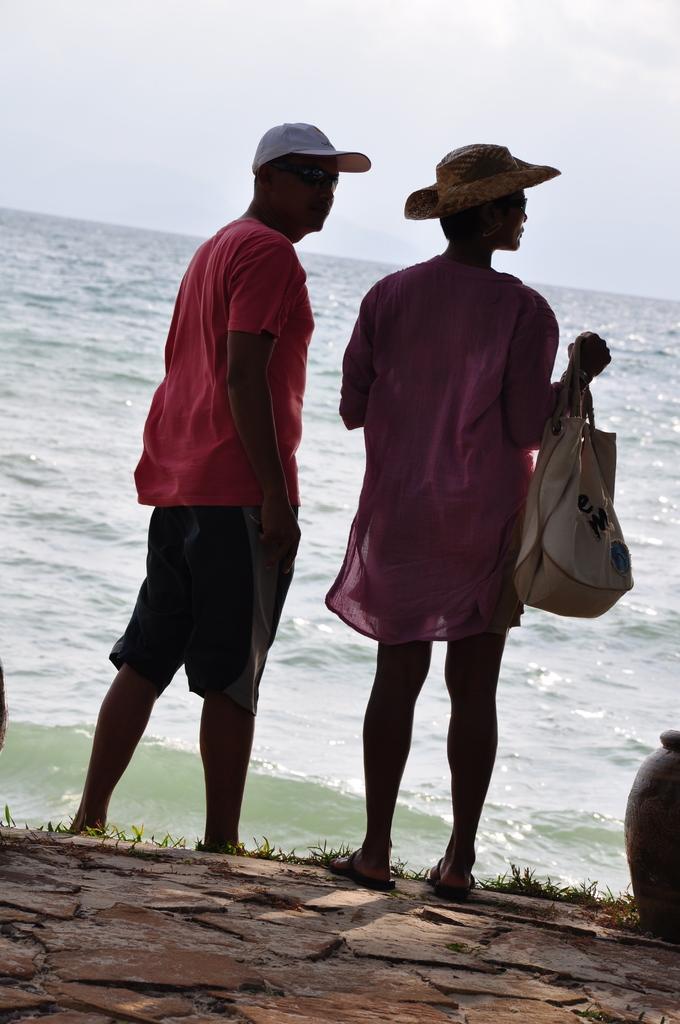How would you summarize this image in a sentence or two? In this image i can see two persons wearing a cap the person standing here holding a bag,at the back ground i can see water and a sky. 